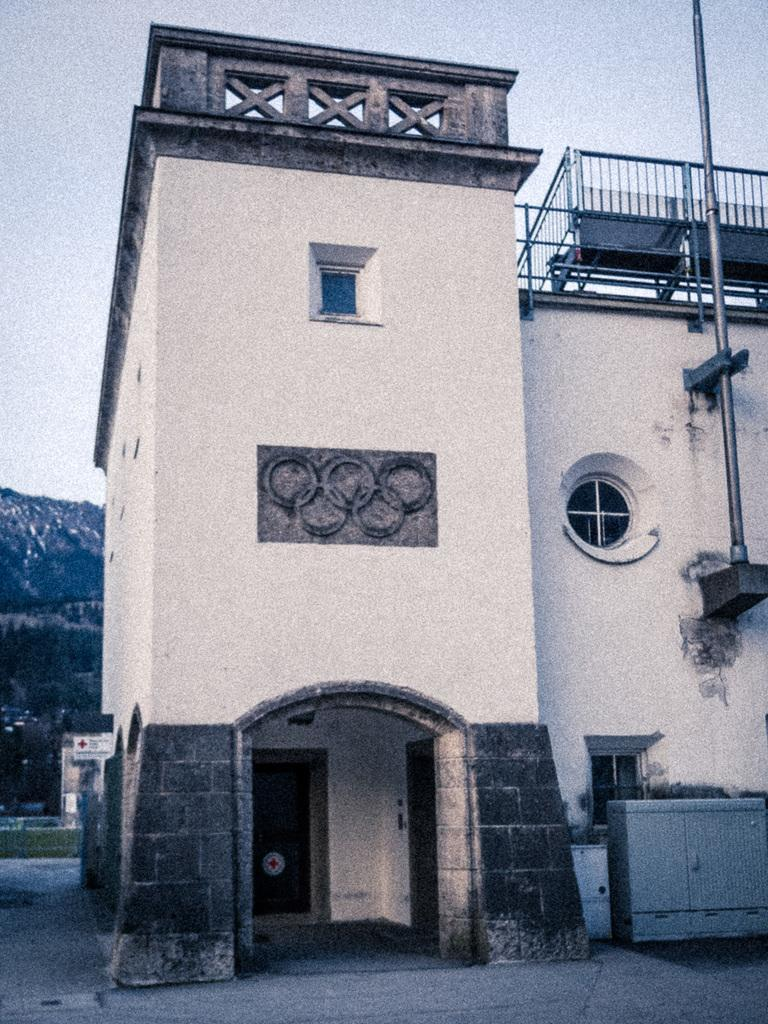What type of structure is visible in the image? There is a building in the image. Where is the entrance to the building located? There is a door at the bottom of the building. What is positioned to the right of the building? There is a pole to the right of the building. What is at the bottom of the image? There is a road at the bottom of the image. What natural feature can be seen to the left of the image? There is a mountain to the left of the image. How much sugar is present on the pole in the image? There is no sugar present on the pole in the image. What type of carriage can be seen traveling along the road in the image? There is no carriage visible in the image; only a building, a door, a pole, a road, and a mountain are present. 